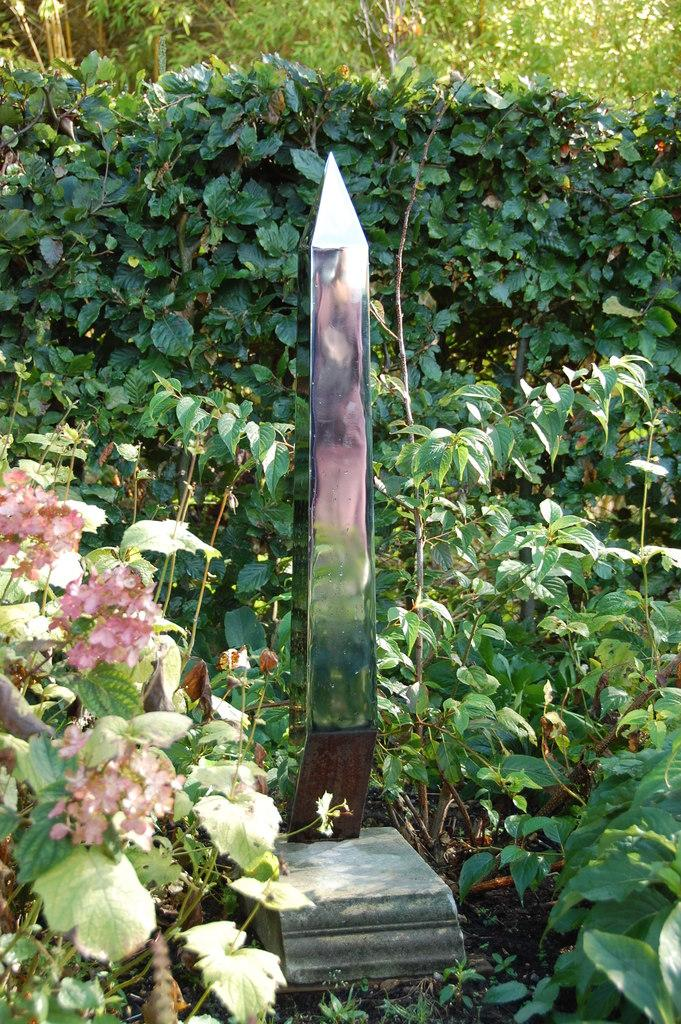What type of structure is on the rock in the image? There is a metal structure on a rock in the image. Where is the rock located? The rock is on the surface in the image. What type of vegetation can be seen in the image? There are trees, plants, and flowers in the image. What type of error can be seen in the image? There is no error present in the image. Where is the stove located in the image? There is no stove present in the image. 